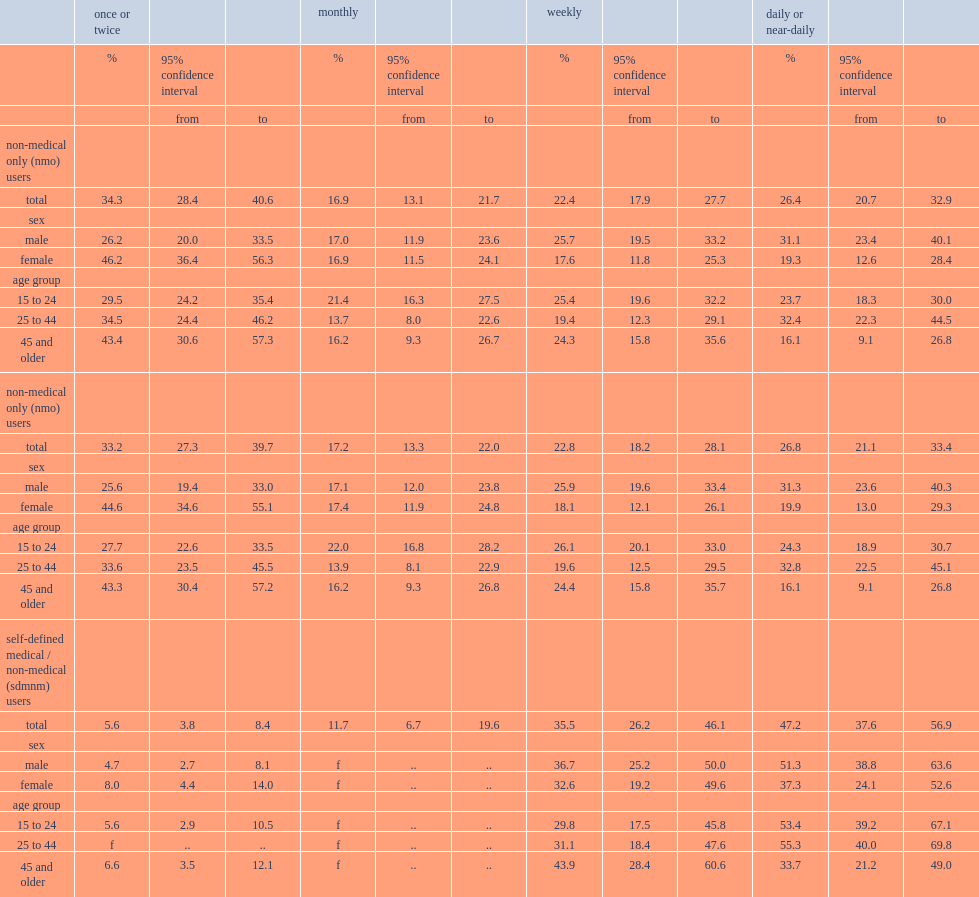What was the percentage of nmo users with daily or near daily use in the previous 3 months ? 26.4. What was the percentage of sdmnm users who reported using cannabis daily or near-daily? 47.2. Who were more common for daily or near-daily use by nmo users,males or females? Male. What were the percentages of sdmnm users aged 25 to 44 who reported using cannabis daily-near daily and sdmnm users aged 45 or older respectively? 55.3 33.7. 